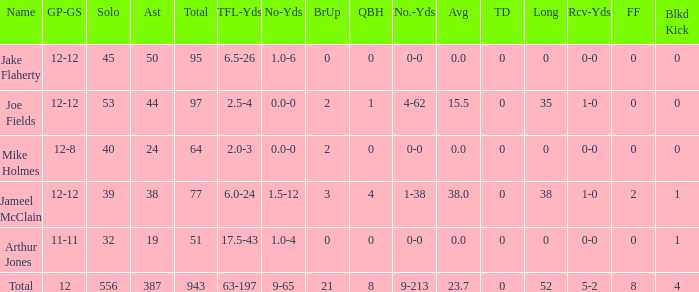How many tackle assists for the player who averages 23.7? 387.0. 